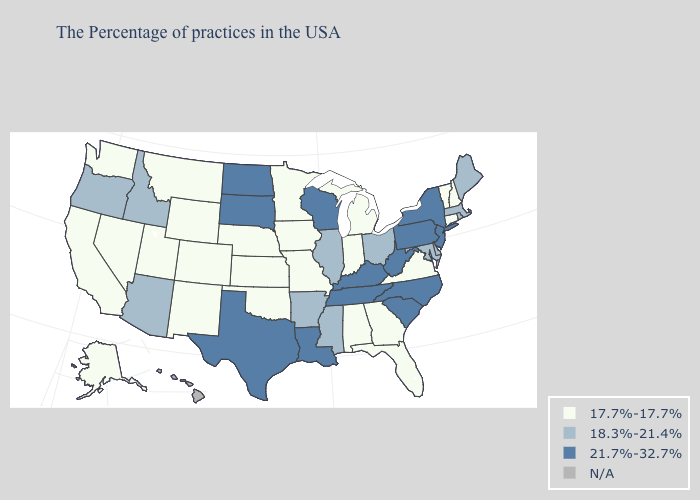Name the states that have a value in the range 17.7%-17.7%?
Write a very short answer. New Hampshire, Vermont, Connecticut, Virginia, Florida, Georgia, Michigan, Indiana, Alabama, Missouri, Minnesota, Iowa, Kansas, Nebraska, Oklahoma, Wyoming, Colorado, New Mexico, Utah, Montana, Nevada, California, Washington, Alaska. Name the states that have a value in the range 17.7%-17.7%?
Be succinct. New Hampshire, Vermont, Connecticut, Virginia, Florida, Georgia, Michigan, Indiana, Alabama, Missouri, Minnesota, Iowa, Kansas, Nebraska, Oklahoma, Wyoming, Colorado, New Mexico, Utah, Montana, Nevada, California, Washington, Alaska. What is the highest value in the MidWest ?
Be succinct. 21.7%-32.7%. Does Tennessee have the highest value in the USA?
Give a very brief answer. Yes. Name the states that have a value in the range N/A?
Concise answer only. Hawaii. Is the legend a continuous bar?
Give a very brief answer. No. What is the value of Montana?
Answer briefly. 17.7%-17.7%. Does the map have missing data?
Short answer required. Yes. What is the value of Virginia?
Short answer required. 17.7%-17.7%. What is the value of Vermont?
Keep it brief. 17.7%-17.7%. Among the states that border Nebraska , does South Dakota have the highest value?
Answer briefly. Yes. Which states have the lowest value in the USA?
Be succinct. New Hampshire, Vermont, Connecticut, Virginia, Florida, Georgia, Michigan, Indiana, Alabama, Missouri, Minnesota, Iowa, Kansas, Nebraska, Oklahoma, Wyoming, Colorado, New Mexico, Utah, Montana, Nevada, California, Washington, Alaska. What is the value of Kansas?
Answer briefly. 17.7%-17.7%. 